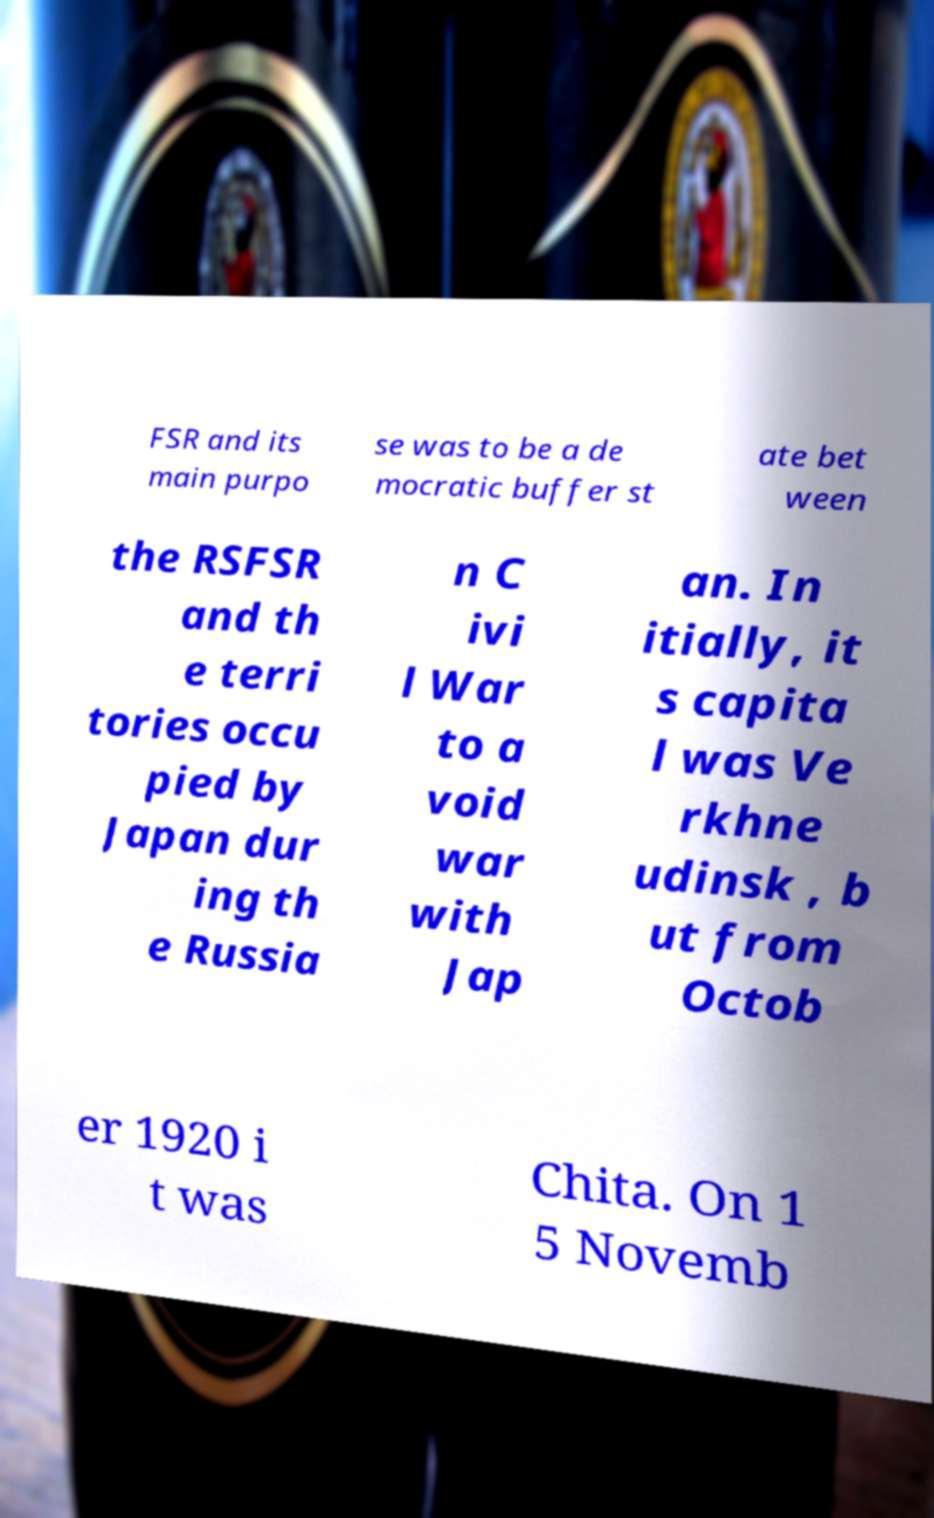Please identify and transcribe the text found in this image. FSR and its main purpo se was to be a de mocratic buffer st ate bet ween the RSFSR and th e terri tories occu pied by Japan dur ing th e Russia n C ivi l War to a void war with Jap an. In itially, it s capita l was Ve rkhne udinsk , b ut from Octob er 1920 i t was Chita. On 1 5 Novemb 